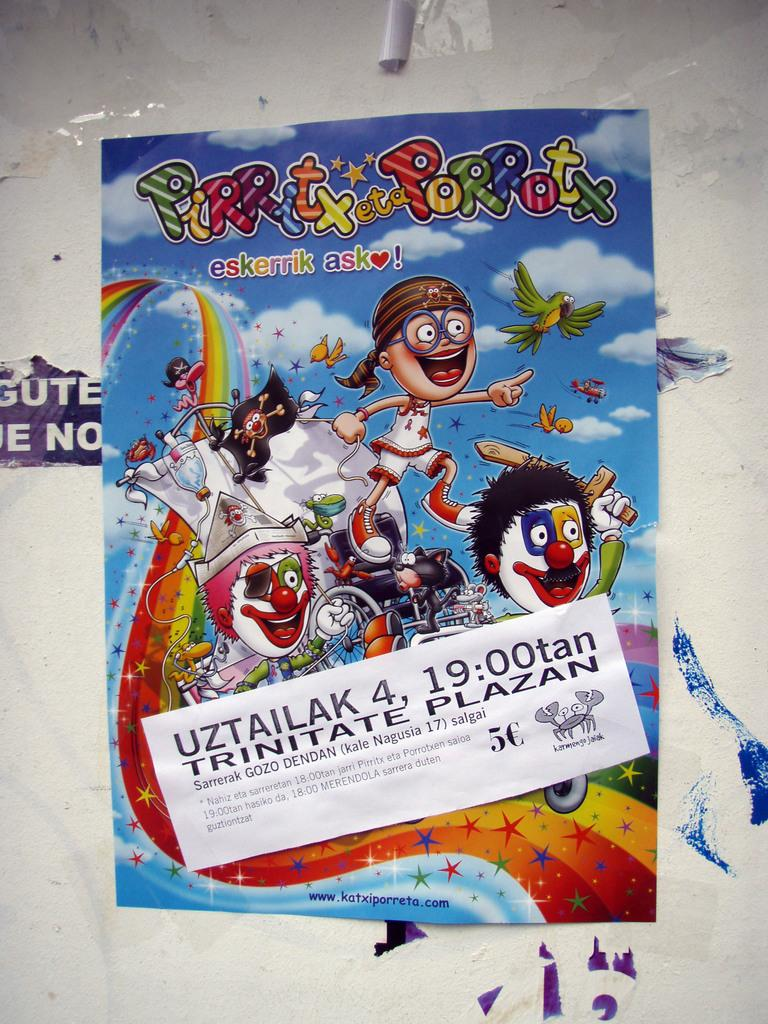<image>
Render a clear and concise summary of the photo. A colorful poster that says Pirritx eta Porrotx. 